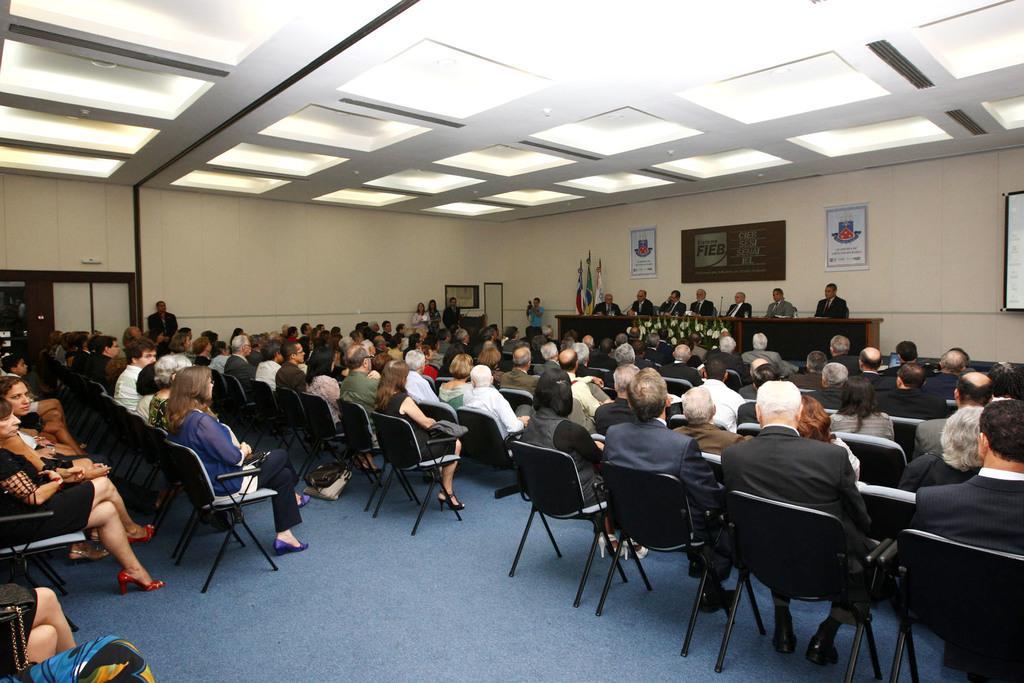Could you give a brief overview of what you see in this image? This image is taken in the auditorium. In this image we can see many people sitting on the chairs which are on the floor. We can also see the some people sitting in front of the table on the stage. We can also see the miles, flags and some frames attached to the plain wall. At the top there is ceiling with the lights. We can also see the doors. 